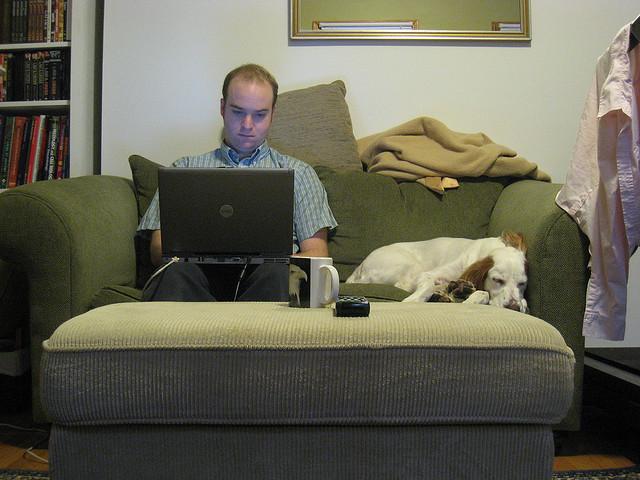Which animals is this?
Concise answer only. Dog. Is the human balding?
Give a very brief answer. Yes. What type animal is laying on the couch?
Short answer required. Dog. What color is the man's shirt?
Short answer required. Blue and white. How many cats are shown?
Keep it brief. 0. What is the man doing?
Write a very short answer. Using laptop. 